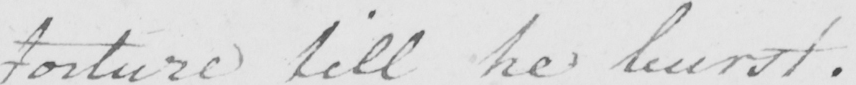Transcribe the text shown in this historical manuscript line. torture till he burst . 